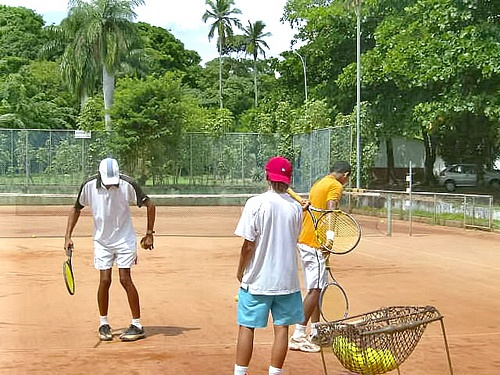Describe the objects in this image and their specific colors. I can see people in white, darkgray, gray, and lightblue tones, people in white, darkgray, and maroon tones, people in white, orange, gold, and tan tones, tennis racket in white, khaki, tan, and ivory tones, and tennis racket in white, tan, and darkgray tones in this image. 